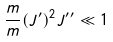<formula> <loc_0><loc_0><loc_500><loc_500>\frac { m } { m } { ( J ^ { \prime } ) ^ { 2 } } { J ^ { \prime \prime } } \ll 1</formula> 